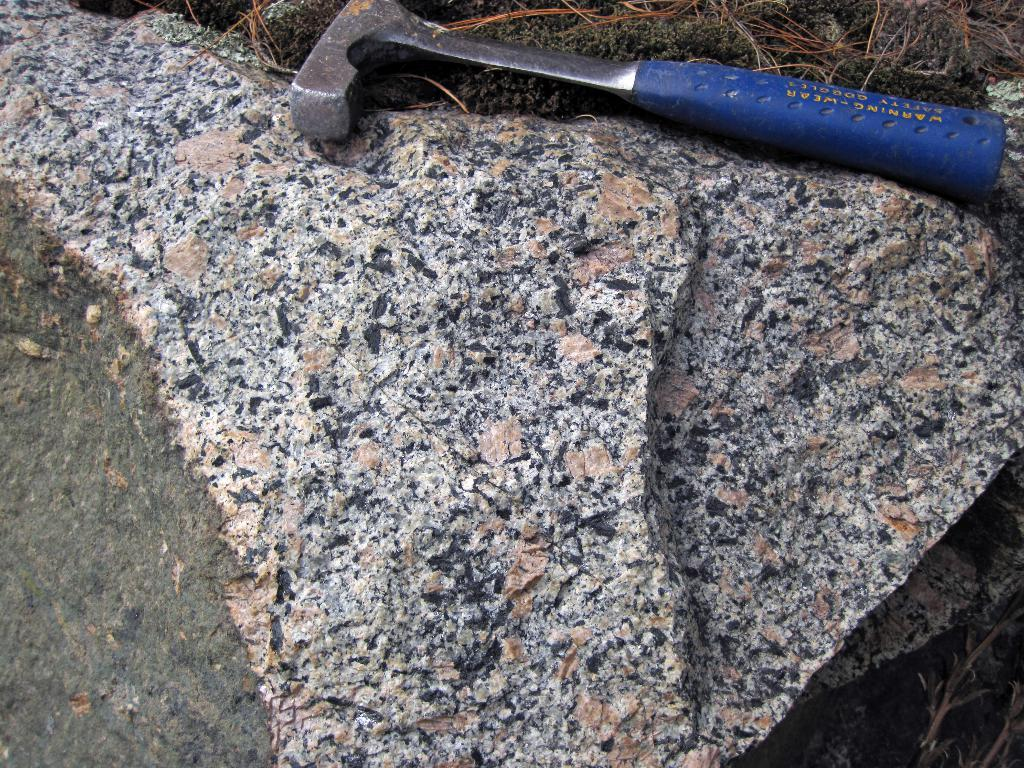What object can be seen in the image? There is a hammer in the image. What is the hammer placed on? The hammer is on rocks. What type of natural environment is visible in the background of the image? There is grass visible in the background of the image. What type of attraction is present in the image? There is no attraction present in the image; it features a hammer on rocks with grass visible in the background. 